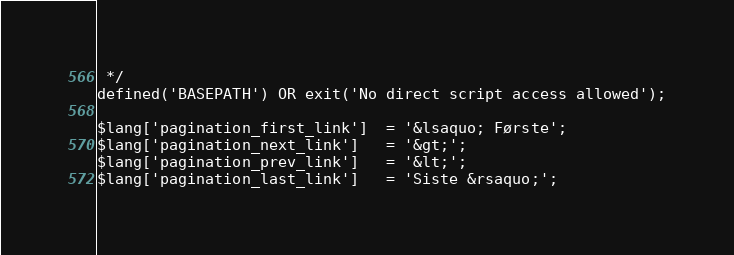Convert code to text. <code><loc_0><loc_0><loc_500><loc_500><_PHP_> */
defined('BASEPATH') OR exit('No direct script access allowed');

$lang['pagination_first_link']	= '&lsaquo; Første';
$lang['pagination_next_link']	= '&gt;';
$lang['pagination_prev_link']	= '&lt;';
$lang['pagination_last_link']	= 'Siste &rsaquo;';
</code> 